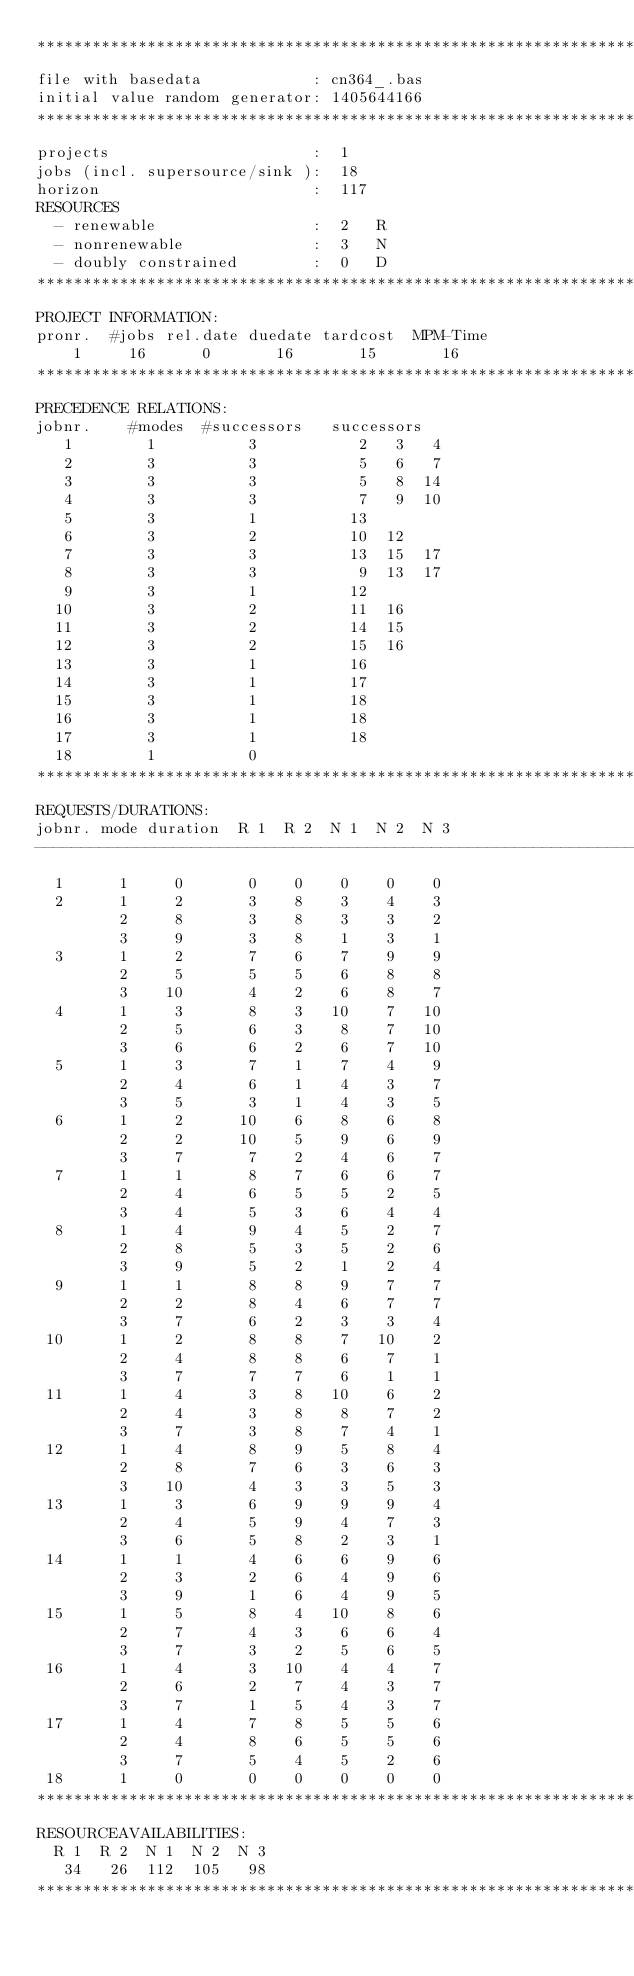Convert code to text. <code><loc_0><loc_0><loc_500><loc_500><_ObjectiveC_>************************************************************************
file with basedata            : cn364_.bas
initial value random generator: 1405644166
************************************************************************
projects                      :  1
jobs (incl. supersource/sink ):  18
horizon                       :  117
RESOURCES
  - renewable                 :  2   R
  - nonrenewable              :  3   N
  - doubly constrained        :  0   D
************************************************************************
PROJECT INFORMATION:
pronr.  #jobs rel.date duedate tardcost  MPM-Time
    1     16      0       16       15       16
************************************************************************
PRECEDENCE RELATIONS:
jobnr.    #modes  #successors   successors
   1        1          3           2   3   4
   2        3          3           5   6   7
   3        3          3           5   8  14
   4        3          3           7   9  10
   5        3          1          13
   6        3          2          10  12
   7        3          3          13  15  17
   8        3          3           9  13  17
   9        3          1          12
  10        3          2          11  16
  11        3          2          14  15
  12        3          2          15  16
  13        3          1          16
  14        3          1          17
  15        3          1          18
  16        3          1          18
  17        3          1          18
  18        1          0        
************************************************************************
REQUESTS/DURATIONS:
jobnr. mode duration  R 1  R 2  N 1  N 2  N 3
------------------------------------------------------------------------
  1      1     0       0    0    0    0    0
  2      1     2       3    8    3    4    3
         2     8       3    8    3    3    2
         3     9       3    8    1    3    1
  3      1     2       7    6    7    9    9
         2     5       5    5    6    8    8
         3    10       4    2    6    8    7
  4      1     3       8    3   10    7   10
         2     5       6    3    8    7   10
         3     6       6    2    6    7   10
  5      1     3       7    1    7    4    9
         2     4       6    1    4    3    7
         3     5       3    1    4    3    5
  6      1     2      10    6    8    6    8
         2     2      10    5    9    6    9
         3     7       7    2    4    6    7
  7      1     1       8    7    6    6    7
         2     4       6    5    5    2    5
         3     4       5    3    6    4    4
  8      1     4       9    4    5    2    7
         2     8       5    3    5    2    6
         3     9       5    2    1    2    4
  9      1     1       8    8    9    7    7
         2     2       8    4    6    7    7
         3     7       6    2    3    3    4
 10      1     2       8    8    7   10    2
         2     4       8    8    6    7    1
         3     7       7    7    6    1    1
 11      1     4       3    8   10    6    2
         2     4       3    8    8    7    2
         3     7       3    8    7    4    1
 12      1     4       8    9    5    8    4
         2     8       7    6    3    6    3
         3    10       4    3    3    5    3
 13      1     3       6    9    9    9    4
         2     4       5    9    4    7    3
         3     6       5    8    2    3    1
 14      1     1       4    6    6    9    6
         2     3       2    6    4    9    6
         3     9       1    6    4    9    5
 15      1     5       8    4   10    8    6
         2     7       4    3    6    6    4
         3     7       3    2    5    6    5
 16      1     4       3   10    4    4    7
         2     6       2    7    4    3    7
         3     7       1    5    4    3    7
 17      1     4       7    8    5    5    6
         2     4       8    6    5    5    6
         3     7       5    4    5    2    6
 18      1     0       0    0    0    0    0
************************************************************************
RESOURCEAVAILABILITIES:
  R 1  R 2  N 1  N 2  N 3
   34   26  112  105   98
************************************************************************
</code> 